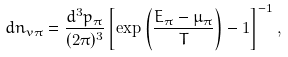Convert formula to latex. <formula><loc_0><loc_0><loc_500><loc_500>d n _ { v \pi } = \frac { d ^ { 3 } p _ { \pi } } { ( 2 \pi ) ^ { 3 } } \left [ \exp \left ( \frac { E _ { \pi } - \mu _ { \pi } } { T } \right ) - 1 \right ] ^ { - 1 } ,</formula> 